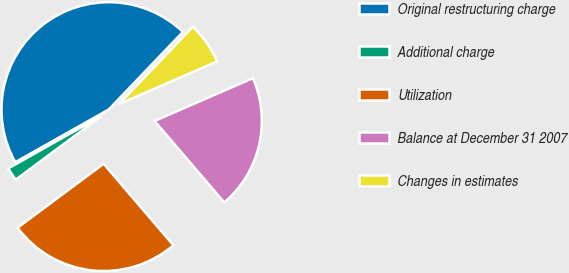<chart> <loc_0><loc_0><loc_500><loc_500><pie_chart><fcel>Original restructuring charge<fcel>Additional charge<fcel>Utilization<fcel>Balance at December 31 2007<fcel>Changes in estimates<nl><fcel>45.31%<fcel>2.0%<fcel>26.09%<fcel>20.27%<fcel>6.33%<nl></chart> 